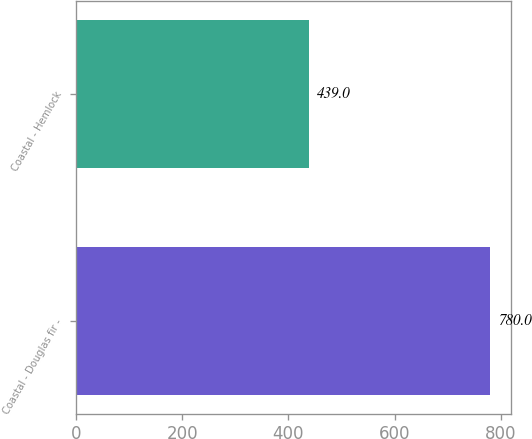Convert chart to OTSL. <chart><loc_0><loc_0><loc_500><loc_500><bar_chart><fcel>Coastal - Douglas fir -<fcel>Coastal - Hemlock<nl><fcel>780<fcel>439<nl></chart> 